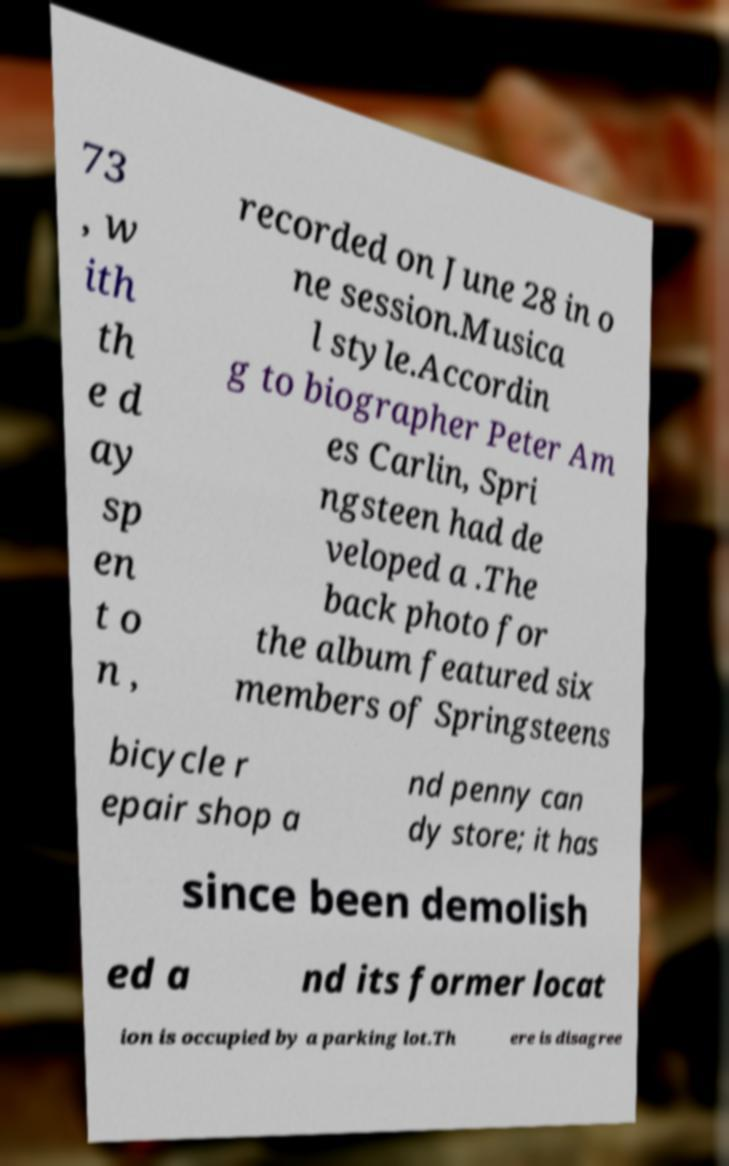Could you assist in decoding the text presented in this image and type it out clearly? 73 , w ith th e d ay sp en t o n , recorded on June 28 in o ne session.Musica l style.Accordin g to biographer Peter Am es Carlin, Spri ngsteen had de veloped a .The back photo for the album featured six members of Springsteens bicycle r epair shop a nd penny can dy store; it has since been demolish ed a nd its former locat ion is occupied by a parking lot.Th ere is disagree 